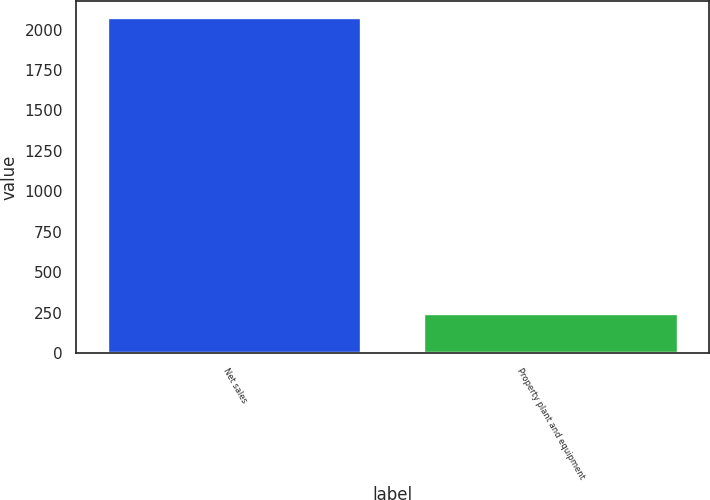<chart> <loc_0><loc_0><loc_500><loc_500><bar_chart><fcel>Net sales<fcel>Property plant and equipment<nl><fcel>2071.2<fcel>239.1<nl></chart> 